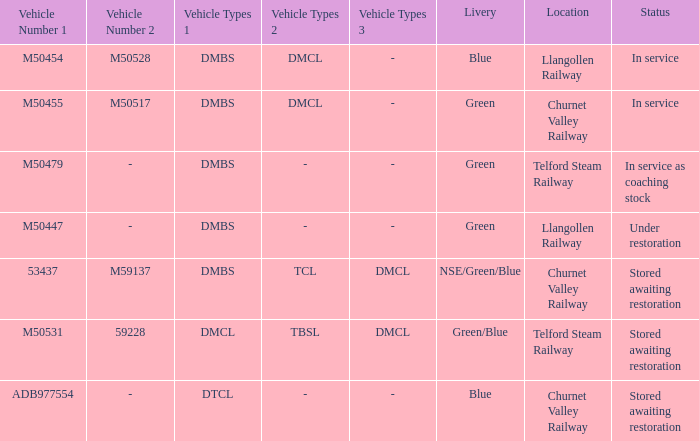What livery has a status of in service as coaching stock? Green. 